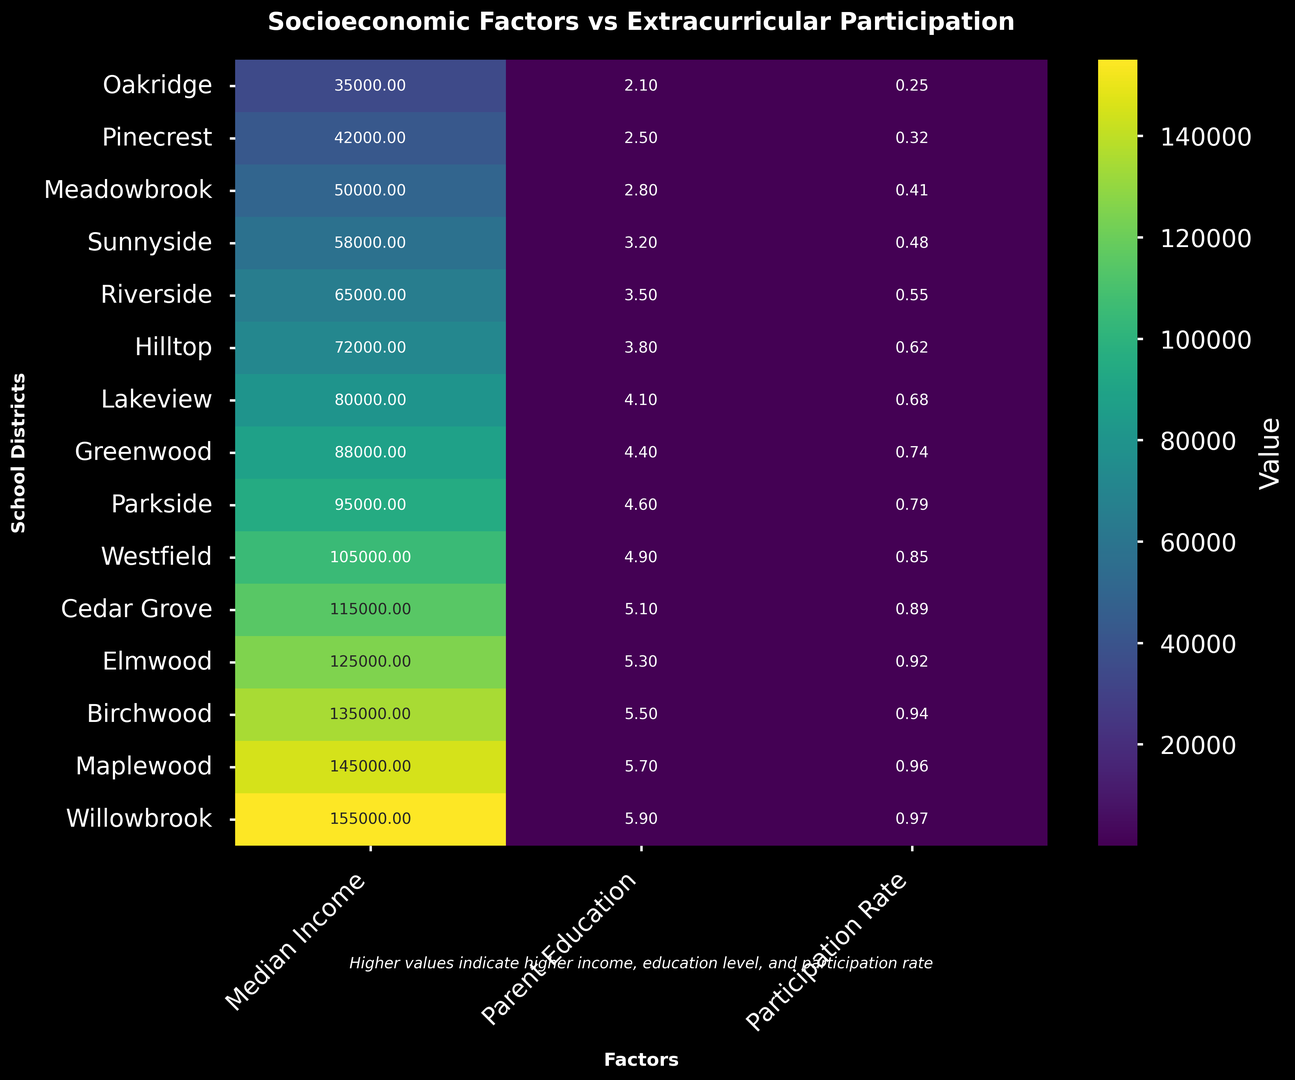What is the median income in the district with the highest extracurricular participation rate? The figure shows that Willowbrook has the highest extracurricular participation rate (0.97). The corresponding median income is $155,000.
Answer: $155,000 Which school district has the highest parent education level? According to the heatmap, Willowbrook has the highest parent education level with a value of 5.9.
Answer: Willowbrook Compare the extracurricular participation rates between Oakridge and Parkside. Which one is higher and by how much? Oakridge has a participation rate of 0.25, and Parkside has a participation rate of 0.79. The difference is 0.79 - 0.25 = 0.54.
Answer: Parkside by 0.54 What is the average parent education level across all school districts? Sum all the parent education levels: (2.1 + 2.5 + 2.8 + 3.2 + 3.5 + 3.8 + 4.1 + 4.4 + 4.6 + 4.9 + 5.1 + 5.3 + 5.5 + 5.7 + 5.9) = 63.8. There are 15 school districts, so the average is 63.8 / 15 ≈ 4.25.
Answer: ≈ 4.25 Identify the district with the lowest median income and describe its extracurricular participation rate. The lowest median income is in Oakridge at $35,000. The extracurricular participation rate for Oakridge is 0.25.
Answer: Oakridge, 0.25 Which district shows the greatest disparity between median income and extracurricular participation rate? Cedar Grove has a median income of $115,000 and a participation rate of 0.89. Compare it with others to note if it deviates prominently, but better details require more steps, focusing only on visible disparities.
Answer: Cedar Grove If districts are color-coded by median income, which ones tend to display cooler colors (e.g., lower values)? Generally, Oakridge to Sunnyside display cooler colors indicating lower median incomes. These districts represent the lower bounds of the income spectrum.
Answer: Oakridge to Sunnyside How do the colors differ for districts with high vs. low parent education levels? Districts with higher parent education levels (e.g., Willowbrook, Maplewood) display warmer colors. Conversely, districts with lower levels (e.g., Oakridge, Pinecrest) are cooler. Warmer colors indicate higher education levels.
Answer: Warmer for high, cooler for low 